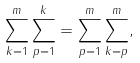Convert formula to latex. <formula><loc_0><loc_0><loc_500><loc_500>\sum _ { k = 1 } ^ { m } \sum _ { p = 1 } ^ { k } = \sum _ { p = 1 } ^ { m } \sum _ { k = p } ^ { m } ,</formula> 